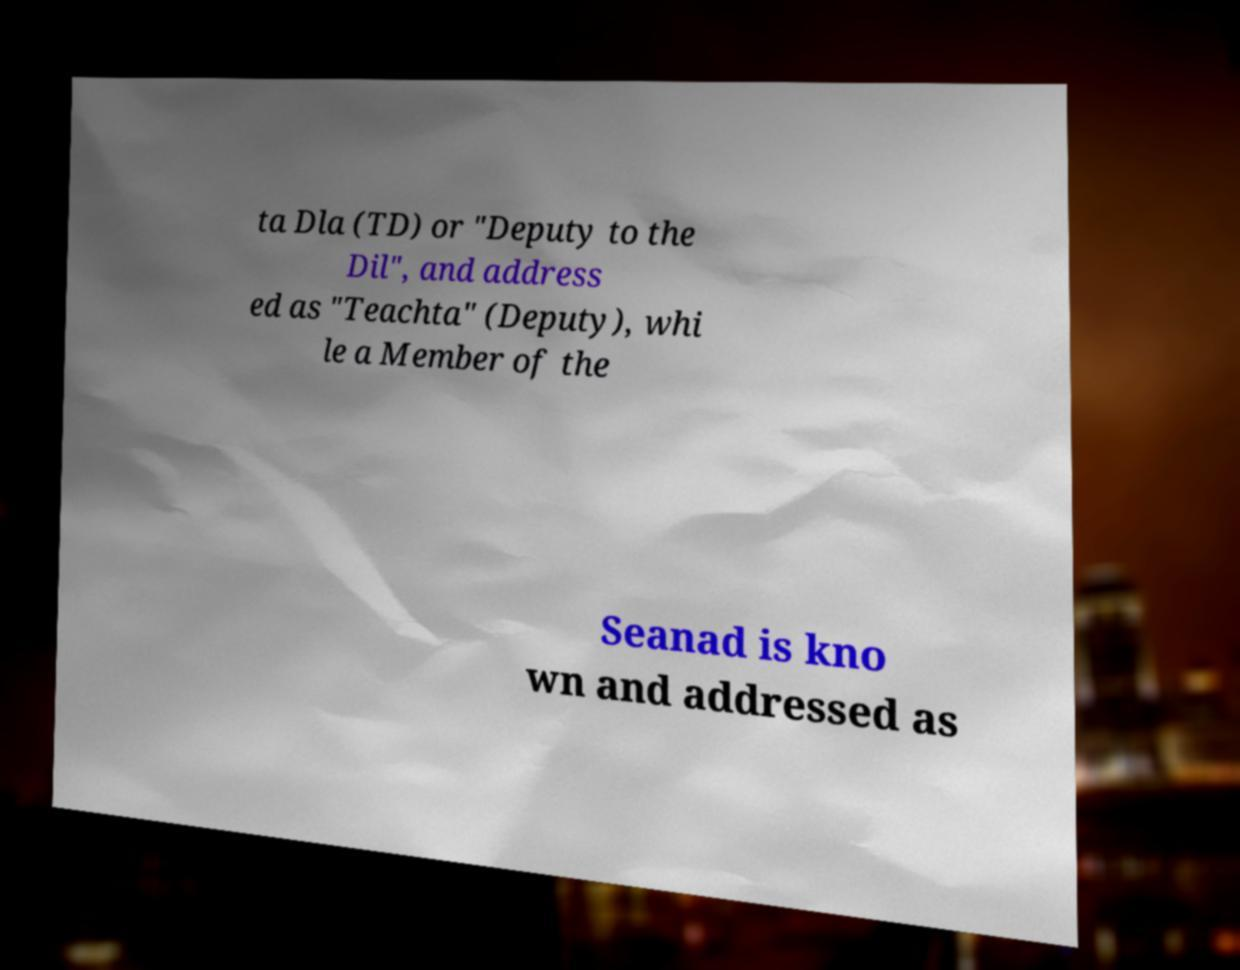Please read and relay the text visible in this image. What does it say? ta Dla (TD) or "Deputy to the Dil", and address ed as "Teachta" (Deputy), whi le a Member of the Seanad is kno wn and addressed as 